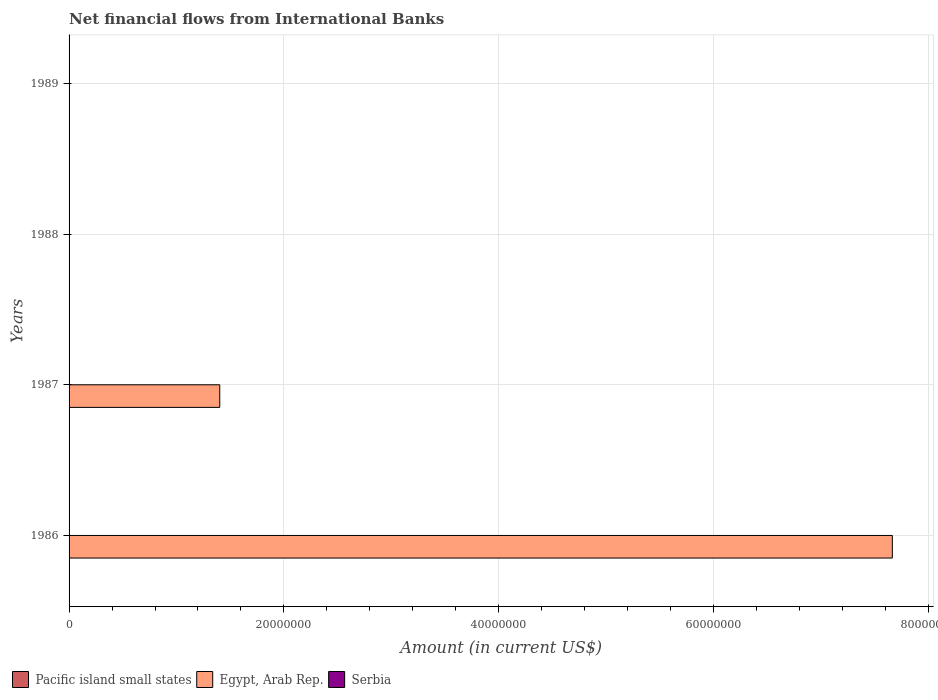Are the number of bars per tick equal to the number of legend labels?
Your answer should be very brief. No. Are the number of bars on each tick of the Y-axis equal?
Give a very brief answer. No. What is the net financial aid flows in Pacific island small states in 1988?
Your answer should be compact. 0. Across all years, what is the maximum net financial aid flows in Egypt, Arab Rep.?
Offer a terse response. 7.66e+07. Across all years, what is the minimum net financial aid flows in Egypt, Arab Rep.?
Your answer should be compact. 0. What is the total net financial aid flows in Egypt, Arab Rep. in the graph?
Give a very brief answer. 9.07e+07. What is the difference between the net financial aid flows in Serbia in 1987 and the net financial aid flows in Egypt, Arab Rep. in 1989?
Ensure brevity in your answer.  0. What is the difference between the highest and the lowest net financial aid flows in Egypt, Arab Rep.?
Keep it short and to the point. 7.66e+07. Is it the case that in every year, the sum of the net financial aid flows in Serbia and net financial aid flows in Egypt, Arab Rep. is greater than the net financial aid flows in Pacific island small states?
Make the answer very short. No. How many years are there in the graph?
Provide a succinct answer. 4. What is the difference between two consecutive major ticks on the X-axis?
Make the answer very short. 2.00e+07. Are the values on the major ticks of X-axis written in scientific E-notation?
Your answer should be compact. No. Where does the legend appear in the graph?
Ensure brevity in your answer.  Bottom left. How many legend labels are there?
Your answer should be very brief. 3. How are the legend labels stacked?
Offer a very short reply. Horizontal. What is the title of the graph?
Keep it short and to the point. Net financial flows from International Banks. What is the Amount (in current US$) of Pacific island small states in 1986?
Provide a short and direct response. 0. What is the Amount (in current US$) of Egypt, Arab Rep. in 1986?
Provide a short and direct response. 7.66e+07. What is the Amount (in current US$) in Serbia in 1986?
Make the answer very short. 0. What is the Amount (in current US$) in Pacific island small states in 1987?
Offer a very short reply. 0. What is the Amount (in current US$) in Egypt, Arab Rep. in 1987?
Offer a very short reply. 1.40e+07. What is the Amount (in current US$) in Pacific island small states in 1988?
Provide a short and direct response. 0. What is the Amount (in current US$) in Serbia in 1988?
Give a very brief answer. 0. What is the Amount (in current US$) in Pacific island small states in 1989?
Your answer should be compact. 0. What is the Amount (in current US$) of Serbia in 1989?
Keep it short and to the point. 0. Across all years, what is the maximum Amount (in current US$) of Egypt, Arab Rep.?
Provide a succinct answer. 7.66e+07. What is the total Amount (in current US$) in Egypt, Arab Rep. in the graph?
Provide a short and direct response. 9.07e+07. What is the total Amount (in current US$) of Serbia in the graph?
Your answer should be compact. 0. What is the difference between the Amount (in current US$) of Egypt, Arab Rep. in 1986 and that in 1987?
Keep it short and to the point. 6.26e+07. What is the average Amount (in current US$) in Egypt, Arab Rep. per year?
Your response must be concise. 2.27e+07. What is the ratio of the Amount (in current US$) in Egypt, Arab Rep. in 1986 to that in 1987?
Ensure brevity in your answer.  5.46. What is the difference between the highest and the lowest Amount (in current US$) of Egypt, Arab Rep.?
Offer a terse response. 7.66e+07. 